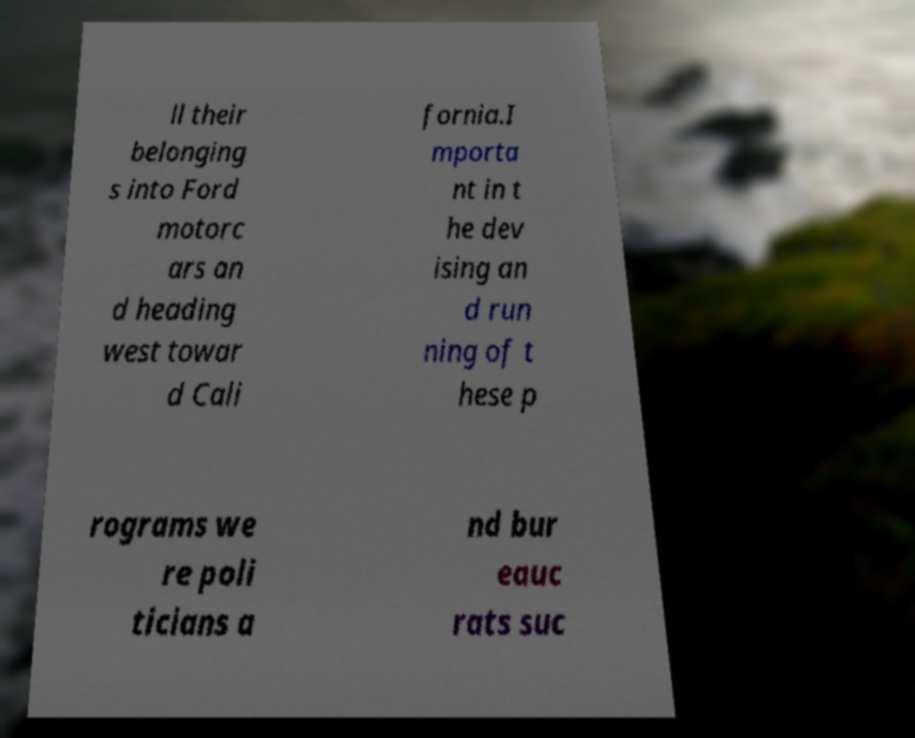Please identify and transcribe the text found in this image. ll their belonging s into Ford motorc ars an d heading west towar d Cali fornia.I mporta nt in t he dev ising an d run ning of t hese p rograms we re poli ticians a nd bur eauc rats suc 